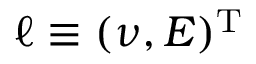<formula> <loc_0><loc_0><loc_500><loc_500>\ell \equiv ( \nu , E ) ^ { T }</formula> 